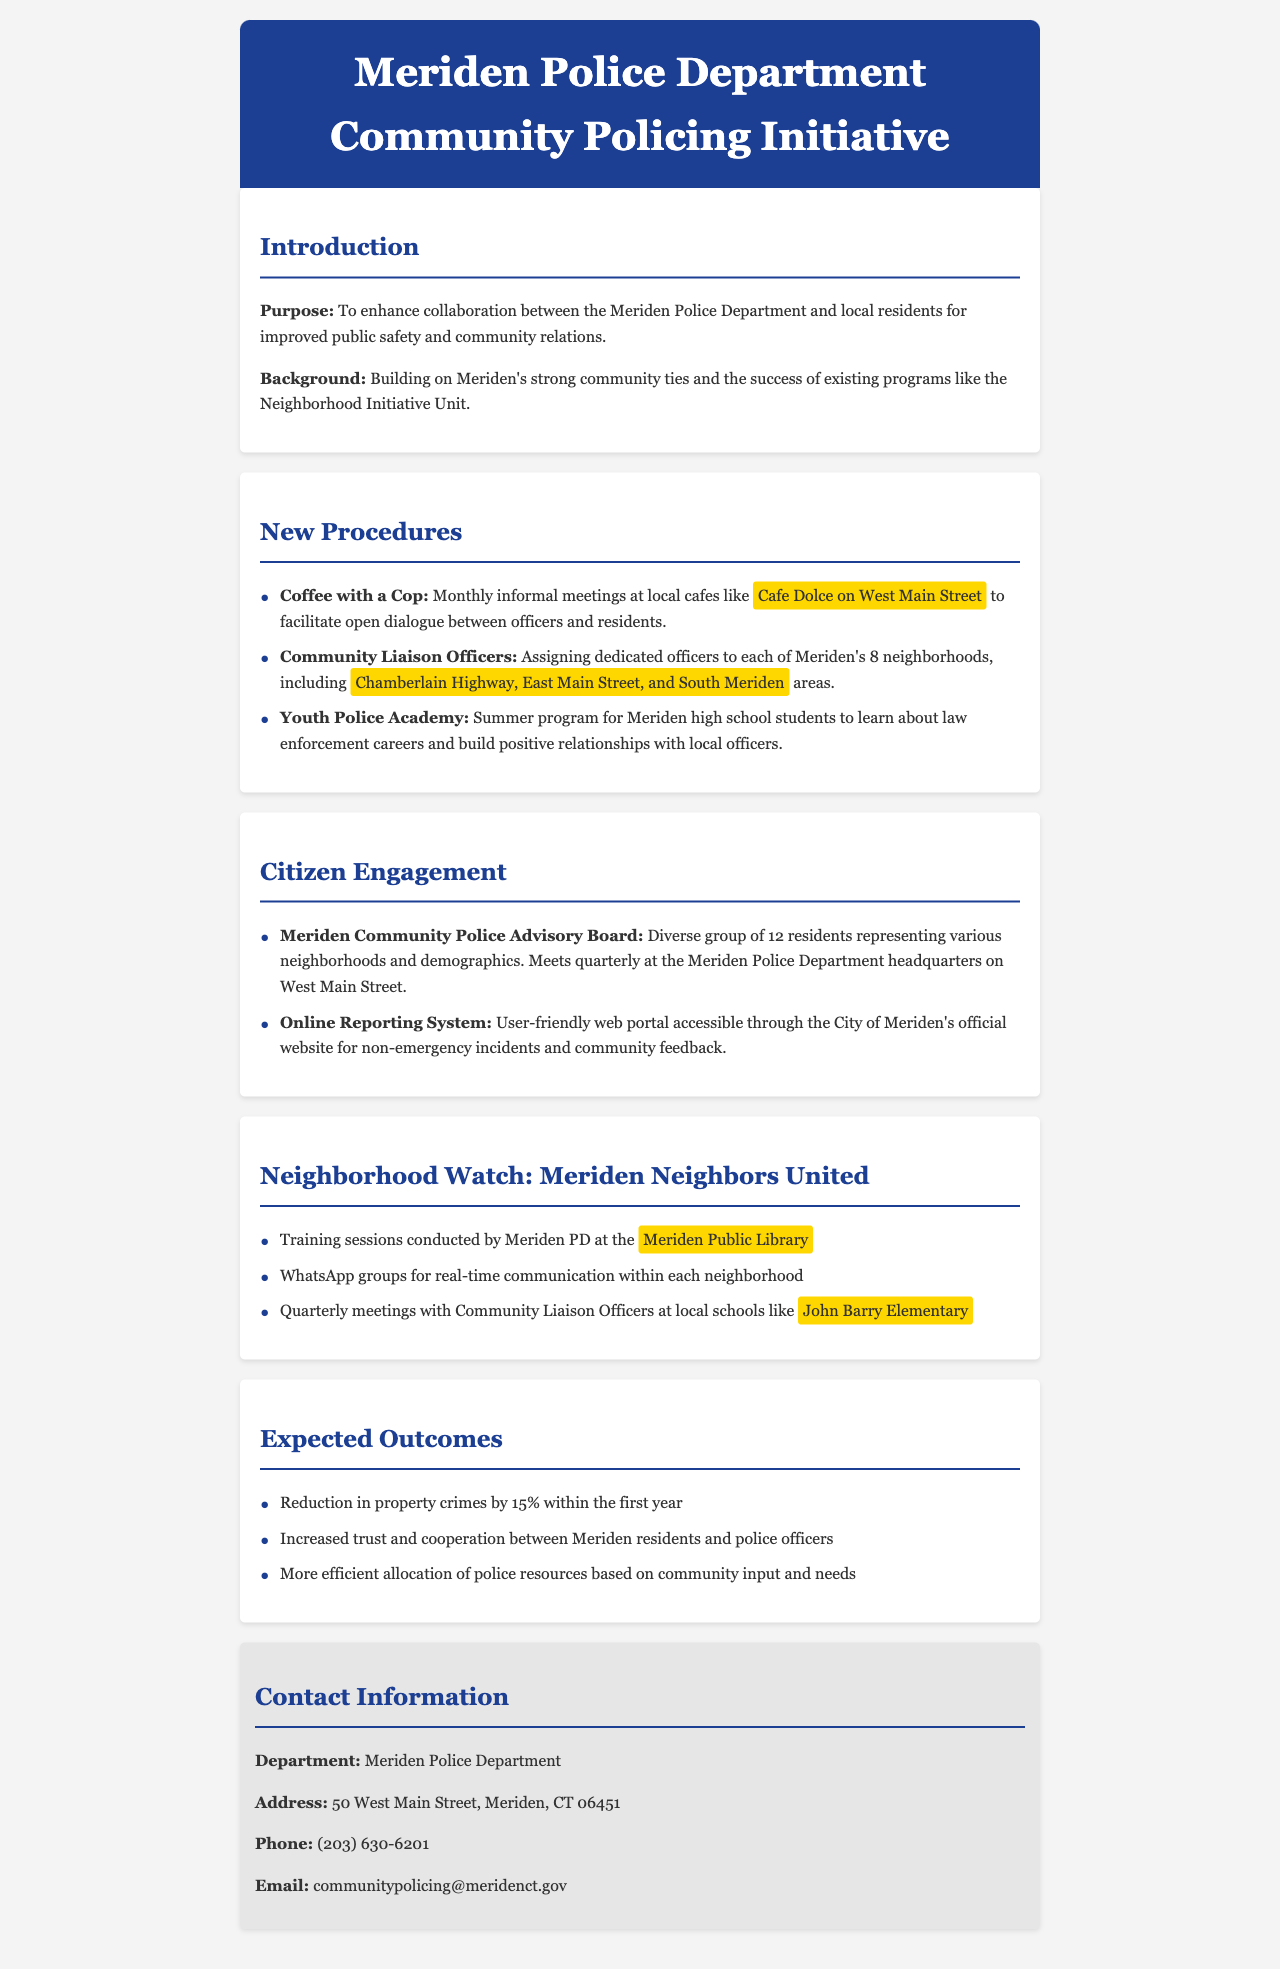What is the purpose of the Community Policing Initiative? The purpose is to enhance collaboration between the Meriden Police Department and local residents for improved public safety and community relations.
Answer: Enhance collaboration How often will the Community Police Advisory Board meet? The document states that the Advisory Board meets quarterly.
Answer: Quarterly Where will the Coffee with a Cop meetings be held? The meetings are held at local cafes like Cafe Dolce on West Main Street.
Answer: Cafe Dolce on West Main Street What is the expected reduction in property crimes within the first year? The expected reduction in property crimes is 15%.
Answer: 15% How many neighborhoods are Community Liaison Officers assigned to in Meriden? The document mentions dedicated officers are assigned to each of Meriden's 8 neighborhoods.
Answer: 8 What program is mentioned for high school students? The Youth Police Academy is a summer program for Meriden high school students.
Answer: Youth Police Academy What type of communication tool will be used in the Neighborhood Watch program? WhatsApp groups will be used for real-time communication within each neighborhood.
Answer: WhatsApp groups Where are the training sessions for the Neighborhood Watch held? Training sessions are conducted by Meriden PD at the Meriden Public Library.
Answer: Meriden Public Library What is the primary goal of the Community Policing Initiative? The primary goal is to improve public safety and community relations.
Answer: Improve public safety and community relations 